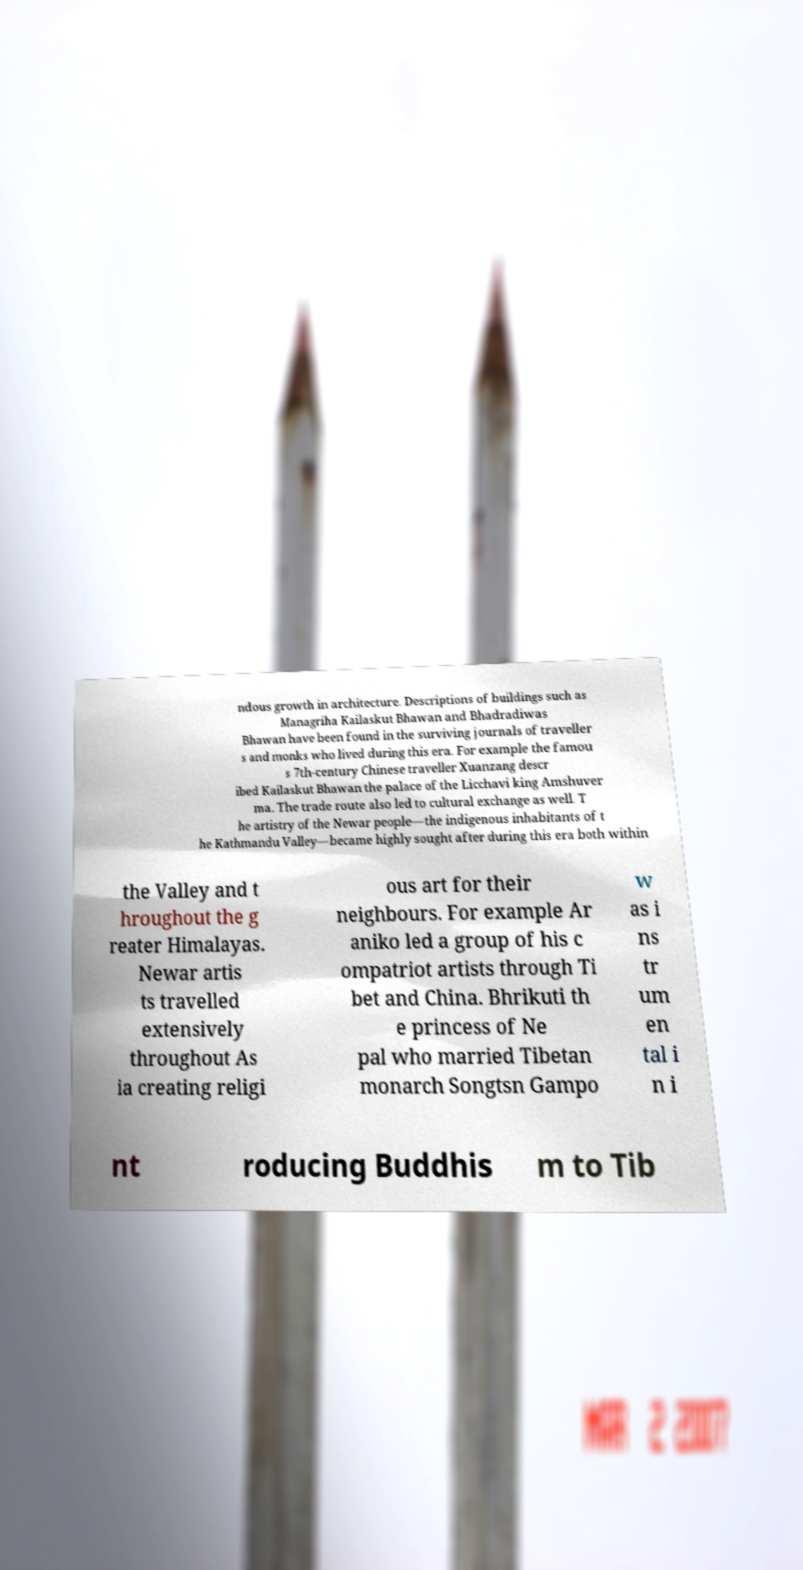Can you read and provide the text displayed in the image?This photo seems to have some interesting text. Can you extract and type it out for me? ndous growth in architecture. Descriptions of buildings such as Managriha Kailaskut Bhawan and Bhadradiwas Bhawan have been found in the surviving journals of traveller s and monks who lived during this era. For example the famou s 7th-century Chinese traveller Xuanzang descr ibed Kailaskut Bhawan the palace of the Licchavi king Amshuver ma. The trade route also led to cultural exchange as well. T he artistry of the Newar people—the indigenous inhabitants of t he Kathmandu Valley—became highly sought after during this era both within the Valley and t hroughout the g reater Himalayas. Newar artis ts travelled extensively throughout As ia creating religi ous art for their neighbours. For example Ar aniko led a group of his c ompatriot artists through Ti bet and China. Bhrikuti th e princess of Ne pal who married Tibetan monarch Songtsn Gampo w as i ns tr um en tal i n i nt roducing Buddhis m to Tib 